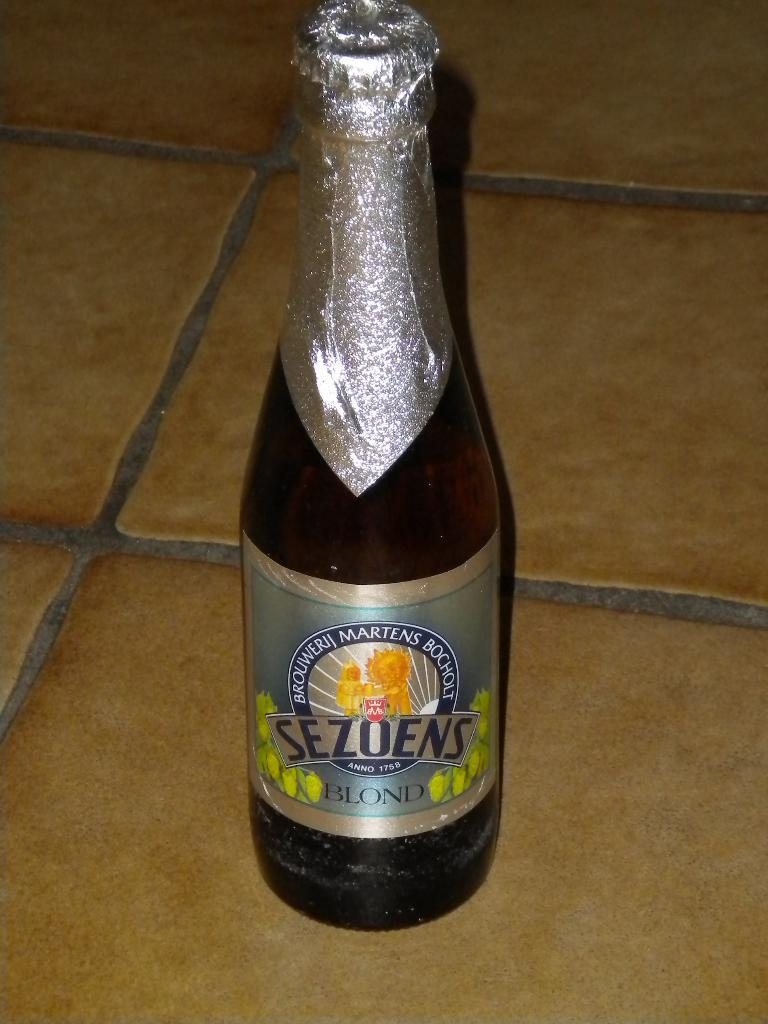<image>
Share a concise interpretation of the image provided. Bottle with a label that says Sezoens on it. 